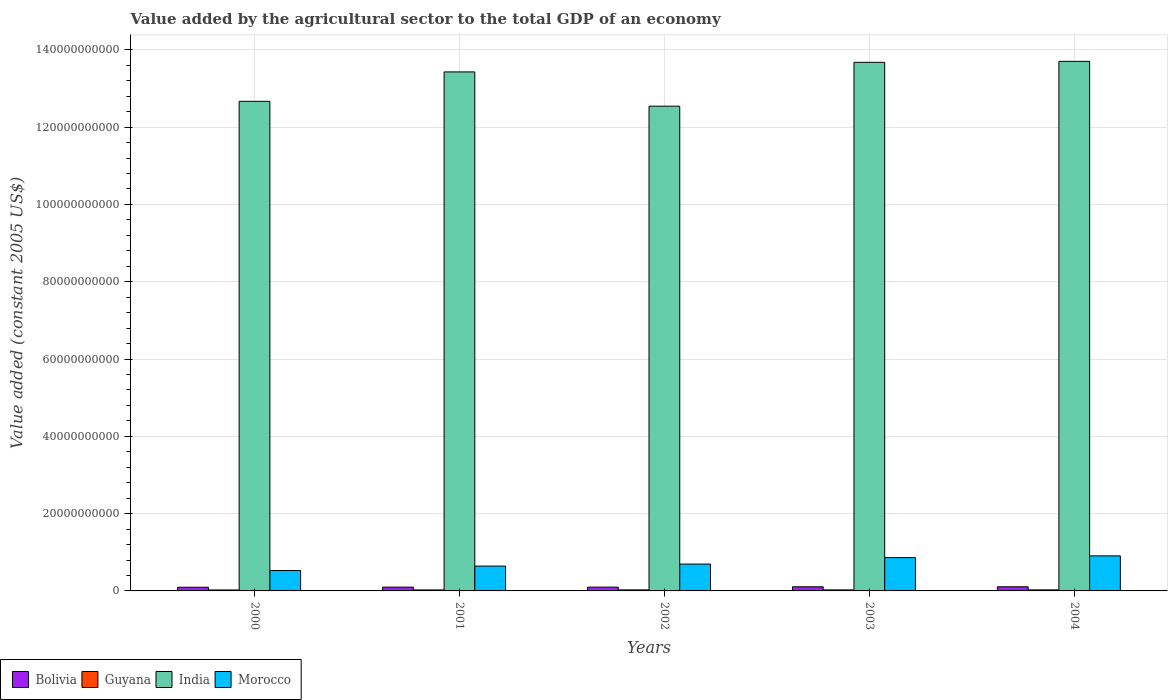How many different coloured bars are there?
Offer a terse response. 4. How many groups of bars are there?
Provide a succinct answer. 5. Are the number of bars on each tick of the X-axis equal?
Keep it short and to the point. Yes. What is the label of the 1st group of bars from the left?
Offer a terse response. 2000. What is the value added by the agricultural sector in Guyana in 2004?
Offer a terse response. 2.69e+08. Across all years, what is the maximum value added by the agricultural sector in Bolivia?
Ensure brevity in your answer.  1.07e+09. Across all years, what is the minimum value added by the agricultural sector in India?
Make the answer very short. 1.25e+11. In which year was the value added by the agricultural sector in India maximum?
Give a very brief answer. 2004. What is the total value added by the agricultural sector in Guyana in the graph?
Ensure brevity in your answer.  1.30e+09. What is the difference between the value added by the agricultural sector in Morocco in 2002 and that in 2004?
Provide a short and direct response. -2.12e+09. What is the difference between the value added by the agricultural sector in Guyana in 2002 and the value added by the agricultural sector in Bolivia in 2004?
Ensure brevity in your answer.  -8.07e+08. What is the average value added by the agricultural sector in India per year?
Make the answer very short. 1.32e+11. In the year 2001, what is the difference between the value added by the agricultural sector in India and value added by the agricultural sector in Guyana?
Offer a terse response. 1.34e+11. What is the ratio of the value added by the agricultural sector in Guyana in 2002 to that in 2004?
Offer a very short reply. 0.98. Is the value added by the agricultural sector in Guyana in 2000 less than that in 2003?
Your response must be concise. Yes. Is the difference between the value added by the agricultural sector in India in 2001 and 2004 greater than the difference between the value added by the agricultural sector in Guyana in 2001 and 2004?
Provide a succinct answer. No. What is the difference between the highest and the second highest value added by the agricultural sector in Morocco?
Offer a very short reply. 4.49e+08. What is the difference between the highest and the lowest value added by the agricultural sector in Bolivia?
Your response must be concise. 1.26e+08. Is the sum of the value added by the agricultural sector in Guyana in 2001 and 2002 greater than the maximum value added by the agricultural sector in Bolivia across all years?
Keep it short and to the point. No. What does the 3rd bar from the right in 2004 represents?
Make the answer very short. Guyana. Is it the case that in every year, the sum of the value added by the agricultural sector in India and value added by the agricultural sector in Bolivia is greater than the value added by the agricultural sector in Guyana?
Provide a succinct answer. Yes. How many years are there in the graph?
Offer a very short reply. 5. Does the graph contain grids?
Your answer should be compact. Yes. Where does the legend appear in the graph?
Ensure brevity in your answer.  Bottom left. How are the legend labels stacked?
Keep it short and to the point. Horizontal. What is the title of the graph?
Give a very brief answer. Value added by the agricultural sector to the total GDP of an economy. Does "Sub-Saharan Africa (developing only)" appear as one of the legend labels in the graph?
Make the answer very short. No. What is the label or title of the Y-axis?
Make the answer very short. Value added (constant 2005 US$). What is the Value added (constant 2005 US$) of Bolivia in 2000?
Provide a succinct answer. 9.47e+08. What is the Value added (constant 2005 US$) in Guyana in 2000?
Ensure brevity in your answer.  2.48e+08. What is the Value added (constant 2005 US$) of India in 2000?
Provide a short and direct response. 1.27e+11. What is the Value added (constant 2005 US$) in Morocco in 2000?
Offer a terse response. 5.28e+09. What is the Value added (constant 2005 US$) of Bolivia in 2001?
Offer a terse response. 9.80e+08. What is the Value added (constant 2005 US$) of Guyana in 2001?
Keep it short and to the point. 2.56e+08. What is the Value added (constant 2005 US$) of India in 2001?
Keep it short and to the point. 1.34e+11. What is the Value added (constant 2005 US$) of Morocco in 2001?
Provide a succinct answer. 6.42e+09. What is the Value added (constant 2005 US$) of Bolivia in 2002?
Make the answer very short. 9.84e+08. What is the Value added (constant 2005 US$) of Guyana in 2002?
Ensure brevity in your answer.  2.65e+08. What is the Value added (constant 2005 US$) of India in 2002?
Provide a succinct answer. 1.25e+11. What is the Value added (constant 2005 US$) of Morocco in 2002?
Your answer should be very brief. 6.95e+09. What is the Value added (constant 2005 US$) of Bolivia in 2003?
Your answer should be very brief. 1.07e+09. What is the Value added (constant 2005 US$) in Guyana in 2003?
Make the answer very short. 2.62e+08. What is the Value added (constant 2005 US$) of India in 2003?
Make the answer very short. 1.37e+11. What is the Value added (constant 2005 US$) of Morocco in 2003?
Provide a short and direct response. 8.62e+09. What is the Value added (constant 2005 US$) in Bolivia in 2004?
Your answer should be compact. 1.07e+09. What is the Value added (constant 2005 US$) in Guyana in 2004?
Keep it short and to the point. 2.69e+08. What is the Value added (constant 2005 US$) of India in 2004?
Keep it short and to the point. 1.37e+11. What is the Value added (constant 2005 US$) of Morocco in 2004?
Your response must be concise. 9.07e+09. Across all years, what is the maximum Value added (constant 2005 US$) in Bolivia?
Make the answer very short. 1.07e+09. Across all years, what is the maximum Value added (constant 2005 US$) of Guyana?
Your answer should be very brief. 2.69e+08. Across all years, what is the maximum Value added (constant 2005 US$) of India?
Keep it short and to the point. 1.37e+11. Across all years, what is the maximum Value added (constant 2005 US$) of Morocco?
Provide a succinct answer. 9.07e+09. Across all years, what is the minimum Value added (constant 2005 US$) in Bolivia?
Offer a very short reply. 9.47e+08. Across all years, what is the minimum Value added (constant 2005 US$) of Guyana?
Your answer should be very brief. 2.48e+08. Across all years, what is the minimum Value added (constant 2005 US$) of India?
Offer a very short reply. 1.25e+11. Across all years, what is the minimum Value added (constant 2005 US$) of Morocco?
Offer a terse response. 5.28e+09. What is the total Value added (constant 2005 US$) in Bolivia in the graph?
Your response must be concise. 5.05e+09. What is the total Value added (constant 2005 US$) of Guyana in the graph?
Ensure brevity in your answer.  1.30e+09. What is the total Value added (constant 2005 US$) of India in the graph?
Offer a very short reply. 6.60e+11. What is the total Value added (constant 2005 US$) of Morocco in the graph?
Your response must be concise. 3.63e+1. What is the difference between the Value added (constant 2005 US$) of Bolivia in 2000 and that in 2001?
Your answer should be compact. -3.28e+07. What is the difference between the Value added (constant 2005 US$) of Guyana in 2000 and that in 2001?
Your response must be concise. -8.48e+06. What is the difference between the Value added (constant 2005 US$) of India in 2000 and that in 2001?
Provide a succinct answer. -7.61e+09. What is the difference between the Value added (constant 2005 US$) in Morocco in 2000 and that in 2001?
Offer a terse response. -1.15e+09. What is the difference between the Value added (constant 2005 US$) of Bolivia in 2000 and that in 2002?
Offer a terse response. -3.72e+07. What is the difference between the Value added (constant 2005 US$) of Guyana in 2000 and that in 2002?
Your answer should be very brief. -1.75e+07. What is the difference between the Value added (constant 2005 US$) of India in 2000 and that in 2002?
Ensure brevity in your answer.  1.26e+09. What is the difference between the Value added (constant 2005 US$) of Morocco in 2000 and that in 2002?
Make the answer very short. -1.67e+09. What is the difference between the Value added (constant 2005 US$) in Bolivia in 2000 and that in 2003?
Ensure brevity in your answer.  -1.23e+08. What is the difference between the Value added (constant 2005 US$) in Guyana in 2000 and that in 2003?
Your answer should be very brief. -1.41e+07. What is the difference between the Value added (constant 2005 US$) in India in 2000 and that in 2003?
Provide a short and direct response. -1.01e+1. What is the difference between the Value added (constant 2005 US$) of Morocco in 2000 and that in 2003?
Your answer should be very brief. -3.34e+09. What is the difference between the Value added (constant 2005 US$) in Bolivia in 2000 and that in 2004?
Your answer should be very brief. -1.26e+08. What is the difference between the Value added (constant 2005 US$) in Guyana in 2000 and that in 2004?
Your response must be concise. -2.16e+07. What is the difference between the Value added (constant 2005 US$) of India in 2000 and that in 2004?
Give a very brief answer. -1.03e+1. What is the difference between the Value added (constant 2005 US$) in Morocco in 2000 and that in 2004?
Offer a very short reply. -3.79e+09. What is the difference between the Value added (constant 2005 US$) in Bolivia in 2001 and that in 2002?
Your response must be concise. -4.38e+06. What is the difference between the Value added (constant 2005 US$) in Guyana in 2001 and that in 2002?
Your answer should be compact. -8.97e+06. What is the difference between the Value added (constant 2005 US$) in India in 2001 and that in 2002?
Offer a terse response. 8.87e+09. What is the difference between the Value added (constant 2005 US$) in Morocco in 2001 and that in 2002?
Give a very brief answer. -5.23e+08. What is the difference between the Value added (constant 2005 US$) of Bolivia in 2001 and that in 2003?
Make the answer very short. -9.01e+07. What is the difference between the Value added (constant 2005 US$) of Guyana in 2001 and that in 2003?
Your response must be concise. -5.58e+06. What is the difference between the Value added (constant 2005 US$) of India in 2001 and that in 2003?
Provide a succinct answer. -2.48e+09. What is the difference between the Value added (constant 2005 US$) of Morocco in 2001 and that in 2003?
Offer a terse response. -2.20e+09. What is the difference between the Value added (constant 2005 US$) in Bolivia in 2001 and that in 2004?
Offer a terse response. -9.28e+07. What is the difference between the Value added (constant 2005 US$) of Guyana in 2001 and that in 2004?
Make the answer very short. -1.31e+07. What is the difference between the Value added (constant 2005 US$) of India in 2001 and that in 2004?
Offer a terse response. -2.73e+09. What is the difference between the Value added (constant 2005 US$) in Morocco in 2001 and that in 2004?
Make the answer very short. -2.65e+09. What is the difference between the Value added (constant 2005 US$) of Bolivia in 2002 and that in 2003?
Keep it short and to the point. -8.58e+07. What is the difference between the Value added (constant 2005 US$) of Guyana in 2002 and that in 2003?
Ensure brevity in your answer.  3.39e+06. What is the difference between the Value added (constant 2005 US$) in India in 2002 and that in 2003?
Offer a terse response. -1.13e+1. What is the difference between the Value added (constant 2005 US$) of Morocco in 2002 and that in 2003?
Offer a terse response. -1.67e+09. What is the difference between the Value added (constant 2005 US$) in Bolivia in 2002 and that in 2004?
Give a very brief answer. -8.84e+07. What is the difference between the Value added (constant 2005 US$) in Guyana in 2002 and that in 2004?
Give a very brief answer. -4.16e+06. What is the difference between the Value added (constant 2005 US$) in India in 2002 and that in 2004?
Provide a succinct answer. -1.16e+1. What is the difference between the Value added (constant 2005 US$) in Morocco in 2002 and that in 2004?
Ensure brevity in your answer.  -2.12e+09. What is the difference between the Value added (constant 2005 US$) in Bolivia in 2003 and that in 2004?
Provide a short and direct response. -2.65e+06. What is the difference between the Value added (constant 2005 US$) of Guyana in 2003 and that in 2004?
Your answer should be compact. -7.55e+06. What is the difference between the Value added (constant 2005 US$) in India in 2003 and that in 2004?
Your answer should be compact. -2.51e+08. What is the difference between the Value added (constant 2005 US$) of Morocco in 2003 and that in 2004?
Your answer should be very brief. -4.49e+08. What is the difference between the Value added (constant 2005 US$) in Bolivia in 2000 and the Value added (constant 2005 US$) in Guyana in 2001?
Ensure brevity in your answer.  6.91e+08. What is the difference between the Value added (constant 2005 US$) of Bolivia in 2000 and the Value added (constant 2005 US$) of India in 2001?
Your answer should be compact. -1.33e+11. What is the difference between the Value added (constant 2005 US$) in Bolivia in 2000 and the Value added (constant 2005 US$) in Morocco in 2001?
Your response must be concise. -5.48e+09. What is the difference between the Value added (constant 2005 US$) in Guyana in 2000 and the Value added (constant 2005 US$) in India in 2001?
Your answer should be very brief. -1.34e+11. What is the difference between the Value added (constant 2005 US$) in Guyana in 2000 and the Value added (constant 2005 US$) in Morocco in 2001?
Your answer should be compact. -6.18e+09. What is the difference between the Value added (constant 2005 US$) in India in 2000 and the Value added (constant 2005 US$) in Morocco in 2001?
Your answer should be very brief. 1.20e+11. What is the difference between the Value added (constant 2005 US$) of Bolivia in 2000 and the Value added (constant 2005 US$) of Guyana in 2002?
Provide a succinct answer. 6.82e+08. What is the difference between the Value added (constant 2005 US$) of Bolivia in 2000 and the Value added (constant 2005 US$) of India in 2002?
Your response must be concise. -1.24e+11. What is the difference between the Value added (constant 2005 US$) in Bolivia in 2000 and the Value added (constant 2005 US$) in Morocco in 2002?
Your answer should be very brief. -6.00e+09. What is the difference between the Value added (constant 2005 US$) of Guyana in 2000 and the Value added (constant 2005 US$) of India in 2002?
Offer a terse response. -1.25e+11. What is the difference between the Value added (constant 2005 US$) of Guyana in 2000 and the Value added (constant 2005 US$) of Morocco in 2002?
Your answer should be very brief. -6.70e+09. What is the difference between the Value added (constant 2005 US$) of India in 2000 and the Value added (constant 2005 US$) of Morocco in 2002?
Make the answer very short. 1.20e+11. What is the difference between the Value added (constant 2005 US$) in Bolivia in 2000 and the Value added (constant 2005 US$) in Guyana in 2003?
Keep it short and to the point. 6.85e+08. What is the difference between the Value added (constant 2005 US$) of Bolivia in 2000 and the Value added (constant 2005 US$) of India in 2003?
Make the answer very short. -1.36e+11. What is the difference between the Value added (constant 2005 US$) of Bolivia in 2000 and the Value added (constant 2005 US$) of Morocco in 2003?
Give a very brief answer. -7.67e+09. What is the difference between the Value added (constant 2005 US$) of Guyana in 2000 and the Value added (constant 2005 US$) of India in 2003?
Your response must be concise. -1.37e+11. What is the difference between the Value added (constant 2005 US$) in Guyana in 2000 and the Value added (constant 2005 US$) in Morocco in 2003?
Offer a terse response. -8.37e+09. What is the difference between the Value added (constant 2005 US$) in India in 2000 and the Value added (constant 2005 US$) in Morocco in 2003?
Offer a terse response. 1.18e+11. What is the difference between the Value added (constant 2005 US$) of Bolivia in 2000 and the Value added (constant 2005 US$) of Guyana in 2004?
Provide a short and direct response. 6.78e+08. What is the difference between the Value added (constant 2005 US$) in Bolivia in 2000 and the Value added (constant 2005 US$) in India in 2004?
Provide a short and direct response. -1.36e+11. What is the difference between the Value added (constant 2005 US$) in Bolivia in 2000 and the Value added (constant 2005 US$) in Morocco in 2004?
Provide a succinct answer. -8.12e+09. What is the difference between the Value added (constant 2005 US$) in Guyana in 2000 and the Value added (constant 2005 US$) in India in 2004?
Make the answer very short. -1.37e+11. What is the difference between the Value added (constant 2005 US$) of Guyana in 2000 and the Value added (constant 2005 US$) of Morocco in 2004?
Your response must be concise. -8.82e+09. What is the difference between the Value added (constant 2005 US$) in India in 2000 and the Value added (constant 2005 US$) in Morocco in 2004?
Keep it short and to the point. 1.18e+11. What is the difference between the Value added (constant 2005 US$) in Bolivia in 2001 and the Value added (constant 2005 US$) in Guyana in 2002?
Offer a very short reply. 7.15e+08. What is the difference between the Value added (constant 2005 US$) of Bolivia in 2001 and the Value added (constant 2005 US$) of India in 2002?
Offer a very short reply. -1.24e+11. What is the difference between the Value added (constant 2005 US$) of Bolivia in 2001 and the Value added (constant 2005 US$) of Morocco in 2002?
Your answer should be very brief. -5.97e+09. What is the difference between the Value added (constant 2005 US$) of Guyana in 2001 and the Value added (constant 2005 US$) of India in 2002?
Your response must be concise. -1.25e+11. What is the difference between the Value added (constant 2005 US$) in Guyana in 2001 and the Value added (constant 2005 US$) in Morocco in 2002?
Your answer should be compact. -6.69e+09. What is the difference between the Value added (constant 2005 US$) in India in 2001 and the Value added (constant 2005 US$) in Morocco in 2002?
Your answer should be very brief. 1.27e+11. What is the difference between the Value added (constant 2005 US$) of Bolivia in 2001 and the Value added (constant 2005 US$) of Guyana in 2003?
Your answer should be very brief. 7.18e+08. What is the difference between the Value added (constant 2005 US$) of Bolivia in 2001 and the Value added (constant 2005 US$) of India in 2003?
Your answer should be very brief. -1.36e+11. What is the difference between the Value added (constant 2005 US$) of Bolivia in 2001 and the Value added (constant 2005 US$) of Morocco in 2003?
Give a very brief answer. -7.64e+09. What is the difference between the Value added (constant 2005 US$) of Guyana in 2001 and the Value added (constant 2005 US$) of India in 2003?
Your answer should be very brief. -1.37e+11. What is the difference between the Value added (constant 2005 US$) in Guyana in 2001 and the Value added (constant 2005 US$) in Morocco in 2003?
Your answer should be very brief. -8.36e+09. What is the difference between the Value added (constant 2005 US$) in India in 2001 and the Value added (constant 2005 US$) in Morocco in 2003?
Keep it short and to the point. 1.26e+11. What is the difference between the Value added (constant 2005 US$) in Bolivia in 2001 and the Value added (constant 2005 US$) in Guyana in 2004?
Make the answer very short. 7.11e+08. What is the difference between the Value added (constant 2005 US$) in Bolivia in 2001 and the Value added (constant 2005 US$) in India in 2004?
Provide a short and direct response. -1.36e+11. What is the difference between the Value added (constant 2005 US$) in Bolivia in 2001 and the Value added (constant 2005 US$) in Morocco in 2004?
Offer a very short reply. -8.09e+09. What is the difference between the Value added (constant 2005 US$) in Guyana in 2001 and the Value added (constant 2005 US$) in India in 2004?
Make the answer very short. -1.37e+11. What is the difference between the Value added (constant 2005 US$) of Guyana in 2001 and the Value added (constant 2005 US$) of Morocco in 2004?
Keep it short and to the point. -8.81e+09. What is the difference between the Value added (constant 2005 US$) of India in 2001 and the Value added (constant 2005 US$) of Morocco in 2004?
Offer a very short reply. 1.25e+11. What is the difference between the Value added (constant 2005 US$) in Bolivia in 2002 and the Value added (constant 2005 US$) in Guyana in 2003?
Your answer should be compact. 7.22e+08. What is the difference between the Value added (constant 2005 US$) of Bolivia in 2002 and the Value added (constant 2005 US$) of India in 2003?
Offer a terse response. -1.36e+11. What is the difference between the Value added (constant 2005 US$) in Bolivia in 2002 and the Value added (constant 2005 US$) in Morocco in 2003?
Give a very brief answer. -7.64e+09. What is the difference between the Value added (constant 2005 US$) of Guyana in 2002 and the Value added (constant 2005 US$) of India in 2003?
Your answer should be very brief. -1.36e+11. What is the difference between the Value added (constant 2005 US$) in Guyana in 2002 and the Value added (constant 2005 US$) in Morocco in 2003?
Your answer should be compact. -8.36e+09. What is the difference between the Value added (constant 2005 US$) in India in 2002 and the Value added (constant 2005 US$) in Morocco in 2003?
Provide a succinct answer. 1.17e+11. What is the difference between the Value added (constant 2005 US$) of Bolivia in 2002 and the Value added (constant 2005 US$) of Guyana in 2004?
Keep it short and to the point. 7.15e+08. What is the difference between the Value added (constant 2005 US$) in Bolivia in 2002 and the Value added (constant 2005 US$) in India in 2004?
Offer a terse response. -1.36e+11. What is the difference between the Value added (constant 2005 US$) of Bolivia in 2002 and the Value added (constant 2005 US$) of Morocco in 2004?
Make the answer very short. -8.09e+09. What is the difference between the Value added (constant 2005 US$) of Guyana in 2002 and the Value added (constant 2005 US$) of India in 2004?
Give a very brief answer. -1.37e+11. What is the difference between the Value added (constant 2005 US$) in Guyana in 2002 and the Value added (constant 2005 US$) in Morocco in 2004?
Offer a very short reply. -8.81e+09. What is the difference between the Value added (constant 2005 US$) of India in 2002 and the Value added (constant 2005 US$) of Morocco in 2004?
Your answer should be compact. 1.16e+11. What is the difference between the Value added (constant 2005 US$) of Bolivia in 2003 and the Value added (constant 2005 US$) of Guyana in 2004?
Your answer should be compact. 8.01e+08. What is the difference between the Value added (constant 2005 US$) of Bolivia in 2003 and the Value added (constant 2005 US$) of India in 2004?
Your answer should be compact. -1.36e+11. What is the difference between the Value added (constant 2005 US$) in Bolivia in 2003 and the Value added (constant 2005 US$) in Morocco in 2004?
Your answer should be very brief. -8.00e+09. What is the difference between the Value added (constant 2005 US$) of Guyana in 2003 and the Value added (constant 2005 US$) of India in 2004?
Your answer should be very brief. -1.37e+11. What is the difference between the Value added (constant 2005 US$) of Guyana in 2003 and the Value added (constant 2005 US$) of Morocco in 2004?
Your answer should be very brief. -8.81e+09. What is the difference between the Value added (constant 2005 US$) in India in 2003 and the Value added (constant 2005 US$) in Morocco in 2004?
Offer a terse response. 1.28e+11. What is the average Value added (constant 2005 US$) in Bolivia per year?
Your response must be concise. 1.01e+09. What is the average Value added (constant 2005 US$) of Guyana per year?
Keep it short and to the point. 2.60e+08. What is the average Value added (constant 2005 US$) of India per year?
Your response must be concise. 1.32e+11. What is the average Value added (constant 2005 US$) in Morocco per year?
Your answer should be very brief. 7.27e+09. In the year 2000, what is the difference between the Value added (constant 2005 US$) of Bolivia and Value added (constant 2005 US$) of Guyana?
Give a very brief answer. 6.99e+08. In the year 2000, what is the difference between the Value added (constant 2005 US$) in Bolivia and Value added (constant 2005 US$) in India?
Your answer should be very brief. -1.26e+11. In the year 2000, what is the difference between the Value added (constant 2005 US$) in Bolivia and Value added (constant 2005 US$) in Morocco?
Your response must be concise. -4.33e+09. In the year 2000, what is the difference between the Value added (constant 2005 US$) in Guyana and Value added (constant 2005 US$) in India?
Offer a very short reply. -1.26e+11. In the year 2000, what is the difference between the Value added (constant 2005 US$) of Guyana and Value added (constant 2005 US$) of Morocco?
Give a very brief answer. -5.03e+09. In the year 2000, what is the difference between the Value added (constant 2005 US$) of India and Value added (constant 2005 US$) of Morocco?
Keep it short and to the point. 1.21e+11. In the year 2001, what is the difference between the Value added (constant 2005 US$) in Bolivia and Value added (constant 2005 US$) in Guyana?
Offer a terse response. 7.24e+08. In the year 2001, what is the difference between the Value added (constant 2005 US$) of Bolivia and Value added (constant 2005 US$) of India?
Ensure brevity in your answer.  -1.33e+11. In the year 2001, what is the difference between the Value added (constant 2005 US$) in Bolivia and Value added (constant 2005 US$) in Morocco?
Provide a short and direct response. -5.44e+09. In the year 2001, what is the difference between the Value added (constant 2005 US$) in Guyana and Value added (constant 2005 US$) in India?
Provide a succinct answer. -1.34e+11. In the year 2001, what is the difference between the Value added (constant 2005 US$) of Guyana and Value added (constant 2005 US$) of Morocco?
Make the answer very short. -6.17e+09. In the year 2001, what is the difference between the Value added (constant 2005 US$) in India and Value added (constant 2005 US$) in Morocco?
Give a very brief answer. 1.28e+11. In the year 2002, what is the difference between the Value added (constant 2005 US$) of Bolivia and Value added (constant 2005 US$) of Guyana?
Offer a very short reply. 7.19e+08. In the year 2002, what is the difference between the Value added (constant 2005 US$) of Bolivia and Value added (constant 2005 US$) of India?
Provide a succinct answer. -1.24e+11. In the year 2002, what is the difference between the Value added (constant 2005 US$) of Bolivia and Value added (constant 2005 US$) of Morocco?
Provide a short and direct response. -5.96e+09. In the year 2002, what is the difference between the Value added (constant 2005 US$) in Guyana and Value added (constant 2005 US$) in India?
Ensure brevity in your answer.  -1.25e+11. In the year 2002, what is the difference between the Value added (constant 2005 US$) in Guyana and Value added (constant 2005 US$) in Morocco?
Provide a short and direct response. -6.68e+09. In the year 2002, what is the difference between the Value added (constant 2005 US$) in India and Value added (constant 2005 US$) in Morocco?
Provide a short and direct response. 1.18e+11. In the year 2003, what is the difference between the Value added (constant 2005 US$) of Bolivia and Value added (constant 2005 US$) of Guyana?
Your answer should be compact. 8.08e+08. In the year 2003, what is the difference between the Value added (constant 2005 US$) in Bolivia and Value added (constant 2005 US$) in India?
Your answer should be very brief. -1.36e+11. In the year 2003, what is the difference between the Value added (constant 2005 US$) of Bolivia and Value added (constant 2005 US$) of Morocco?
Ensure brevity in your answer.  -7.55e+09. In the year 2003, what is the difference between the Value added (constant 2005 US$) in Guyana and Value added (constant 2005 US$) in India?
Provide a short and direct response. -1.36e+11. In the year 2003, what is the difference between the Value added (constant 2005 US$) in Guyana and Value added (constant 2005 US$) in Morocco?
Make the answer very short. -8.36e+09. In the year 2003, what is the difference between the Value added (constant 2005 US$) in India and Value added (constant 2005 US$) in Morocco?
Your answer should be very brief. 1.28e+11. In the year 2004, what is the difference between the Value added (constant 2005 US$) of Bolivia and Value added (constant 2005 US$) of Guyana?
Provide a succinct answer. 8.03e+08. In the year 2004, what is the difference between the Value added (constant 2005 US$) in Bolivia and Value added (constant 2005 US$) in India?
Your answer should be compact. -1.36e+11. In the year 2004, what is the difference between the Value added (constant 2005 US$) of Bolivia and Value added (constant 2005 US$) of Morocco?
Provide a short and direct response. -8.00e+09. In the year 2004, what is the difference between the Value added (constant 2005 US$) in Guyana and Value added (constant 2005 US$) in India?
Make the answer very short. -1.37e+11. In the year 2004, what is the difference between the Value added (constant 2005 US$) of Guyana and Value added (constant 2005 US$) of Morocco?
Your answer should be compact. -8.80e+09. In the year 2004, what is the difference between the Value added (constant 2005 US$) of India and Value added (constant 2005 US$) of Morocco?
Your answer should be very brief. 1.28e+11. What is the ratio of the Value added (constant 2005 US$) in Bolivia in 2000 to that in 2001?
Your answer should be very brief. 0.97. What is the ratio of the Value added (constant 2005 US$) in Guyana in 2000 to that in 2001?
Provide a succinct answer. 0.97. What is the ratio of the Value added (constant 2005 US$) of India in 2000 to that in 2001?
Provide a succinct answer. 0.94. What is the ratio of the Value added (constant 2005 US$) of Morocco in 2000 to that in 2001?
Offer a terse response. 0.82. What is the ratio of the Value added (constant 2005 US$) of Bolivia in 2000 to that in 2002?
Offer a very short reply. 0.96. What is the ratio of the Value added (constant 2005 US$) of Guyana in 2000 to that in 2002?
Make the answer very short. 0.93. What is the ratio of the Value added (constant 2005 US$) in India in 2000 to that in 2002?
Your response must be concise. 1.01. What is the ratio of the Value added (constant 2005 US$) in Morocco in 2000 to that in 2002?
Keep it short and to the point. 0.76. What is the ratio of the Value added (constant 2005 US$) of Bolivia in 2000 to that in 2003?
Offer a terse response. 0.89. What is the ratio of the Value added (constant 2005 US$) in Guyana in 2000 to that in 2003?
Keep it short and to the point. 0.95. What is the ratio of the Value added (constant 2005 US$) in India in 2000 to that in 2003?
Make the answer very short. 0.93. What is the ratio of the Value added (constant 2005 US$) in Morocco in 2000 to that in 2003?
Offer a very short reply. 0.61. What is the ratio of the Value added (constant 2005 US$) in Bolivia in 2000 to that in 2004?
Give a very brief answer. 0.88. What is the ratio of the Value added (constant 2005 US$) in Guyana in 2000 to that in 2004?
Keep it short and to the point. 0.92. What is the ratio of the Value added (constant 2005 US$) of India in 2000 to that in 2004?
Give a very brief answer. 0.92. What is the ratio of the Value added (constant 2005 US$) of Morocco in 2000 to that in 2004?
Offer a terse response. 0.58. What is the ratio of the Value added (constant 2005 US$) of Guyana in 2001 to that in 2002?
Provide a short and direct response. 0.97. What is the ratio of the Value added (constant 2005 US$) in India in 2001 to that in 2002?
Your answer should be compact. 1.07. What is the ratio of the Value added (constant 2005 US$) of Morocco in 2001 to that in 2002?
Keep it short and to the point. 0.92. What is the ratio of the Value added (constant 2005 US$) of Bolivia in 2001 to that in 2003?
Offer a very short reply. 0.92. What is the ratio of the Value added (constant 2005 US$) in Guyana in 2001 to that in 2003?
Your answer should be very brief. 0.98. What is the ratio of the Value added (constant 2005 US$) of India in 2001 to that in 2003?
Keep it short and to the point. 0.98. What is the ratio of the Value added (constant 2005 US$) of Morocco in 2001 to that in 2003?
Keep it short and to the point. 0.75. What is the ratio of the Value added (constant 2005 US$) in Bolivia in 2001 to that in 2004?
Provide a succinct answer. 0.91. What is the ratio of the Value added (constant 2005 US$) of Guyana in 2001 to that in 2004?
Ensure brevity in your answer.  0.95. What is the ratio of the Value added (constant 2005 US$) of India in 2001 to that in 2004?
Your answer should be compact. 0.98. What is the ratio of the Value added (constant 2005 US$) of Morocco in 2001 to that in 2004?
Provide a succinct answer. 0.71. What is the ratio of the Value added (constant 2005 US$) of Bolivia in 2002 to that in 2003?
Your answer should be compact. 0.92. What is the ratio of the Value added (constant 2005 US$) of Guyana in 2002 to that in 2003?
Provide a short and direct response. 1.01. What is the ratio of the Value added (constant 2005 US$) of India in 2002 to that in 2003?
Your answer should be compact. 0.92. What is the ratio of the Value added (constant 2005 US$) in Morocco in 2002 to that in 2003?
Your response must be concise. 0.81. What is the ratio of the Value added (constant 2005 US$) of Bolivia in 2002 to that in 2004?
Offer a very short reply. 0.92. What is the ratio of the Value added (constant 2005 US$) in Guyana in 2002 to that in 2004?
Your answer should be compact. 0.98. What is the ratio of the Value added (constant 2005 US$) of India in 2002 to that in 2004?
Offer a very short reply. 0.92. What is the ratio of the Value added (constant 2005 US$) in Morocco in 2002 to that in 2004?
Your answer should be very brief. 0.77. What is the ratio of the Value added (constant 2005 US$) in Bolivia in 2003 to that in 2004?
Provide a short and direct response. 1. What is the ratio of the Value added (constant 2005 US$) of Morocco in 2003 to that in 2004?
Provide a succinct answer. 0.95. What is the difference between the highest and the second highest Value added (constant 2005 US$) of Bolivia?
Offer a terse response. 2.65e+06. What is the difference between the highest and the second highest Value added (constant 2005 US$) of Guyana?
Give a very brief answer. 4.16e+06. What is the difference between the highest and the second highest Value added (constant 2005 US$) in India?
Keep it short and to the point. 2.51e+08. What is the difference between the highest and the second highest Value added (constant 2005 US$) in Morocco?
Offer a terse response. 4.49e+08. What is the difference between the highest and the lowest Value added (constant 2005 US$) in Bolivia?
Offer a terse response. 1.26e+08. What is the difference between the highest and the lowest Value added (constant 2005 US$) in Guyana?
Provide a succinct answer. 2.16e+07. What is the difference between the highest and the lowest Value added (constant 2005 US$) of India?
Make the answer very short. 1.16e+1. What is the difference between the highest and the lowest Value added (constant 2005 US$) of Morocco?
Give a very brief answer. 3.79e+09. 